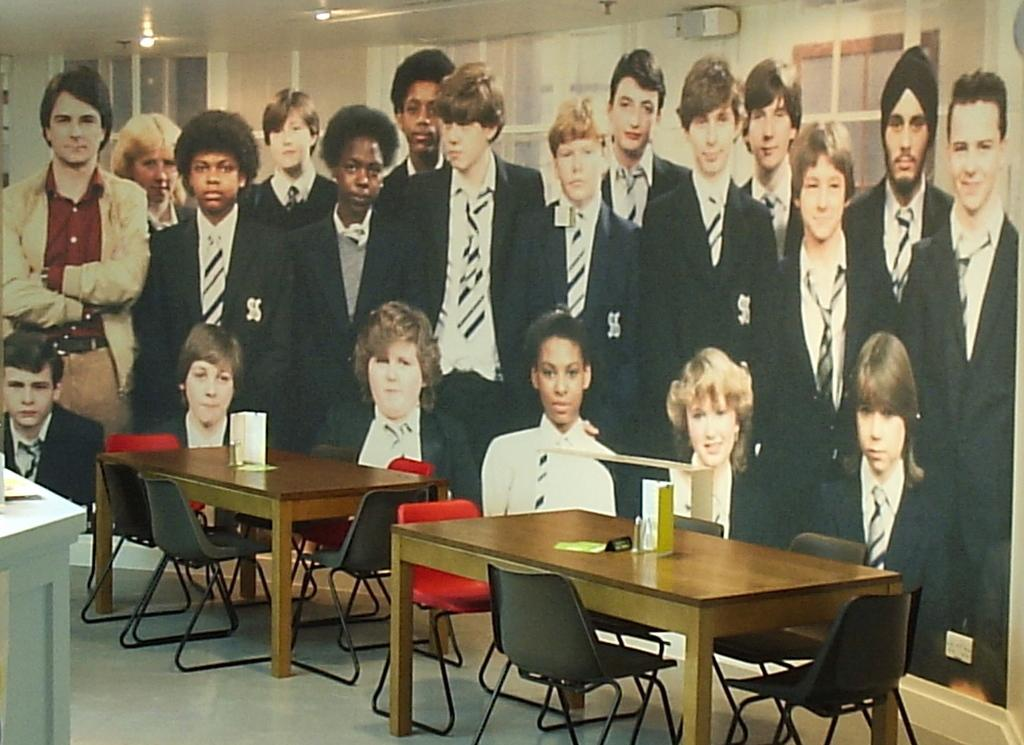What is the main object in the image? There is a board in the image. What is happening on the board? There is a group of people on the board. What objects are in front of the board? There are two tables and at least one chair in front of the board. What shape is the mailbox in the image? There is no mailbox present in the image. 